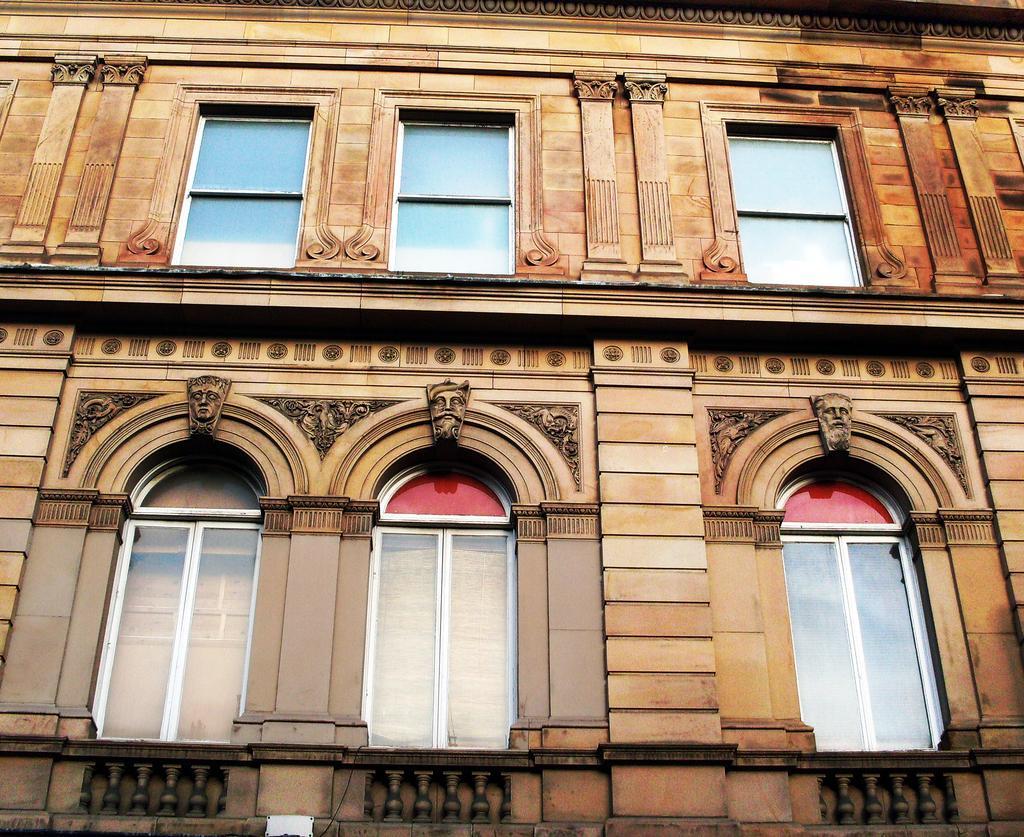In one or two sentences, can you explain what this image depicts? in this picture I can see the building. In the center I can see the windows. At the top of the windows I can see some statues of the persons faces. 